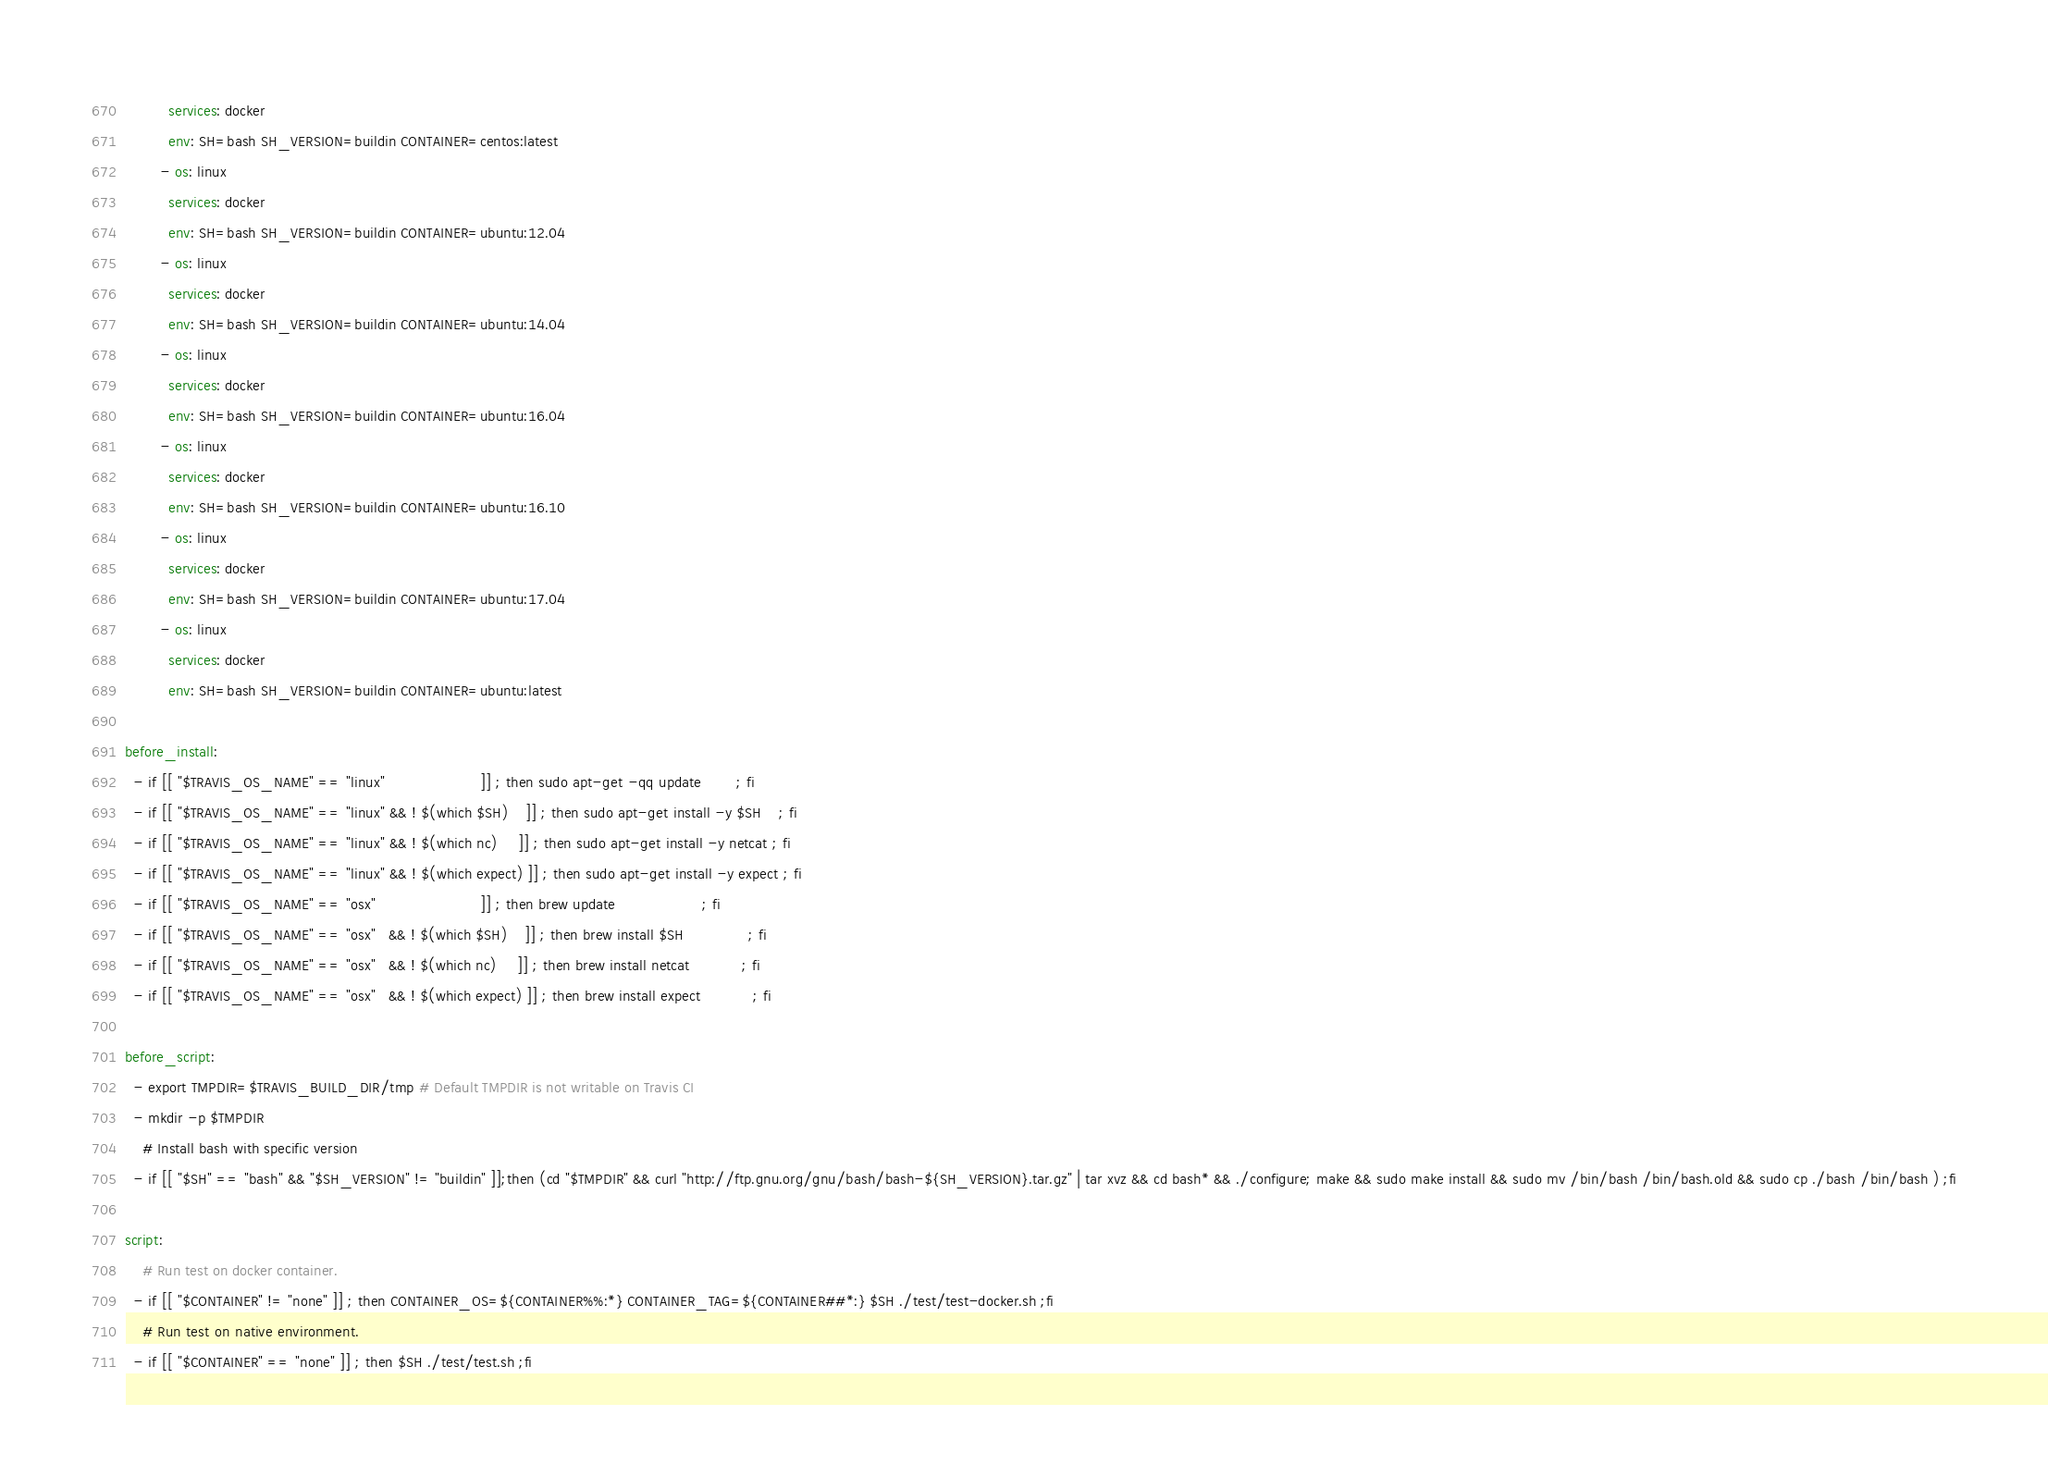<code> <loc_0><loc_0><loc_500><loc_500><_YAML_>          services: docker
          env: SH=bash SH_VERSION=buildin CONTAINER=centos:latest
        - os: linux
          services: docker
          env: SH=bash SH_VERSION=buildin CONTAINER=ubuntu:12.04
        - os: linux
          services: docker
          env: SH=bash SH_VERSION=buildin CONTAINER=ubuntu:14.04
        - os: linux
          services: docker
          env: SH=bash SH_VERSION=buildin CONTAINER=ubuntu:16.04
        - os: linux
          services: docker
          env: SH=bash SH_VERSION=buildin CONTAINER=ubuntu:16.10
        - os: linux
          services: docker
          env: SH=bash SH_VERSION=buildin CONTAINER=ubuntu:17.04
        - os: linux
          services: docker
          env: SH=bash SH_VERSION=buildin CONTAINER=ubuntu:latest

before_install:
  - if [[ "$TRAVIS_OS_NAME" == "linux"                      ]] ; then sudo apt-get -qq update        ; fi
  - if [[ "$TRAVIS_OS_NAME" == "linux" && ! $(which $SH)    ]] ; then sudo apt-get install -y $SH    ; fi
  - if [[ "$TRAVIS_OS_NAME" == "linux" && ! $(which nc)     ]] ; then sudo apt-get install -y netcat ; fi
  - if [[ "$TRAVIS_OS_NAME" == "linux" && ! $(which expect) ]] ; then sudo apt-get install -y expect ; fi
  - if [[ "$TRAVIS_OS_NAME" == "osx"                        ]] ; then brew update                    ; fi
  - if [[ "$TRAVIS_OS_NAME" == "osx"   && ! $(which $SH)    ]] ; then brew install $SH               ; fi
  - if [[ "$TRAVIS_OS_NAME" == "osx"   && ! $(which nc)     ]] ; then brew install netcat            ; fi
  - if [[ "$TRAVIS_OS_NAME" == "osx"   && ! $(which expect) ]] ; then brew install expect            ; fi

before_script:
  - export TMPDIR=$TRAVIS_BUILD_DIR/tmp # Default TMPDIR is not writable on Travis CI
  - mkdir -p $TMPDIR
    # Install bash with specific version
  - if [[ "$SH" == "bash" && "$SH_VERSION" != "buildin" ]];then (cd "$TMPDIR" && curl "http://ftp.gnu.org/gnu/bash/bash-${SH_VERSION}.tar.gz" | tar xvz && cd bash* && ./configure; make && sudo make install && sudo mv /bin/bash /bin/bash.old && sudo cp ./bash /bin/bash ) ;fi

script:
    # Run test on docker container.
  - if [[ "$CONTAINER" != "none" ]] ; then CONTAINER_OS=${CONTAINER%%:*} CONTAINER_TAG=${CONTAINER##*:} $SH ./test/test-docker.sh ;fi
    # Run test on native environment.
  - if [[ "$CONTAINER" == "none" ]] ; then $SH ./test/test.sh ;fi
</code> 